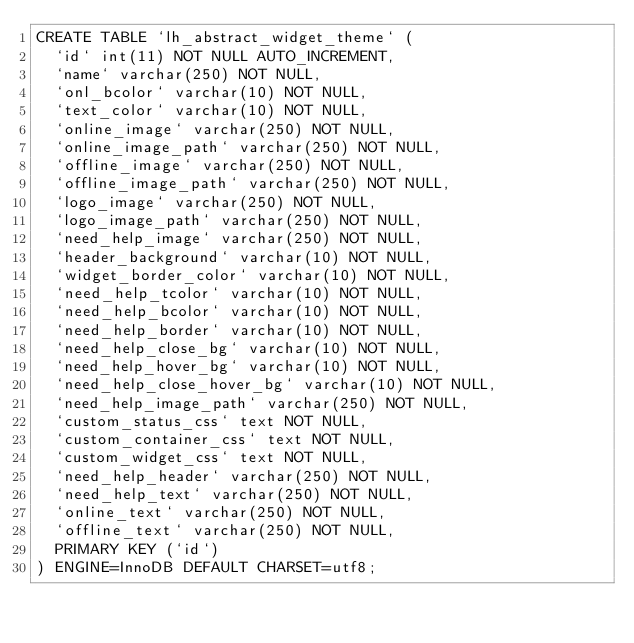Convert code to text. <code><loc_0><loc_0><loc_500><loc_500><_SQL_>CREATE TABLE `lh_abstract_widget_theme` (
  `id` int(11) NOT NULL AUTO_INCREMENT,
  `name` varchar(250) NOT NULL,
  `onl_bcolor` varchar(10) NOT NULL,
  `text_color` varchar(10) NOT NULL,
  `online_image` varchar(250) NOT NULL,
  `online_image_path` varchar(250) NOT NULL,
  `offline_image` varchar(250) NOT NULL,
  `offline_image_path` varchar(250) NOT NULL,
  `logo_image` varchar(250) NOT NULL,
  `logo_image_path` varchar(250) NOT NULL,
  `need_help_image` varchar(250) NOT NULL,
  `header_background` varchar(10) NOT NULL,
  `widget_border_color` varchar(10) NOT NULL,
  `need_help_tcolor` varchar(10) NOT NULL,
  `need_help_bcolor` varchar(10) NOT NULL,
  `need_help_border` varchar(10) NOT NULL,
  `need_help_close_bg` varchar(10) NOT NULL,
  `need_help_hover_bg` varchar(10) NOT NULL,
  `need_help_close_hover_bg` varchar(10) NOT NULL,
  `need_help_image_path` varchar(250) NOT NULL,
  `custom_status_css` text NOT NULL,
  `custom_container_css` text NOT NULL,
  `custom_widget_css` text NOT NULL,
  `need_help_header` varchar(250) NOT NULL,
  `need_help_text` varchar(250) NOT NULL,
  `online_text` varchar(250) NOT NULL,
  `offline_text` varchar(250) NOT NULL,
  PRIMARY KEY (`id`)
) ENGINE=InnoDB DEFAULT CHARSET=utf8;
</code> 